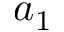Convert formula to latex. <formula><loc_0><loc_0><loc_500><loc_500>a _ { 1 }</formula> 